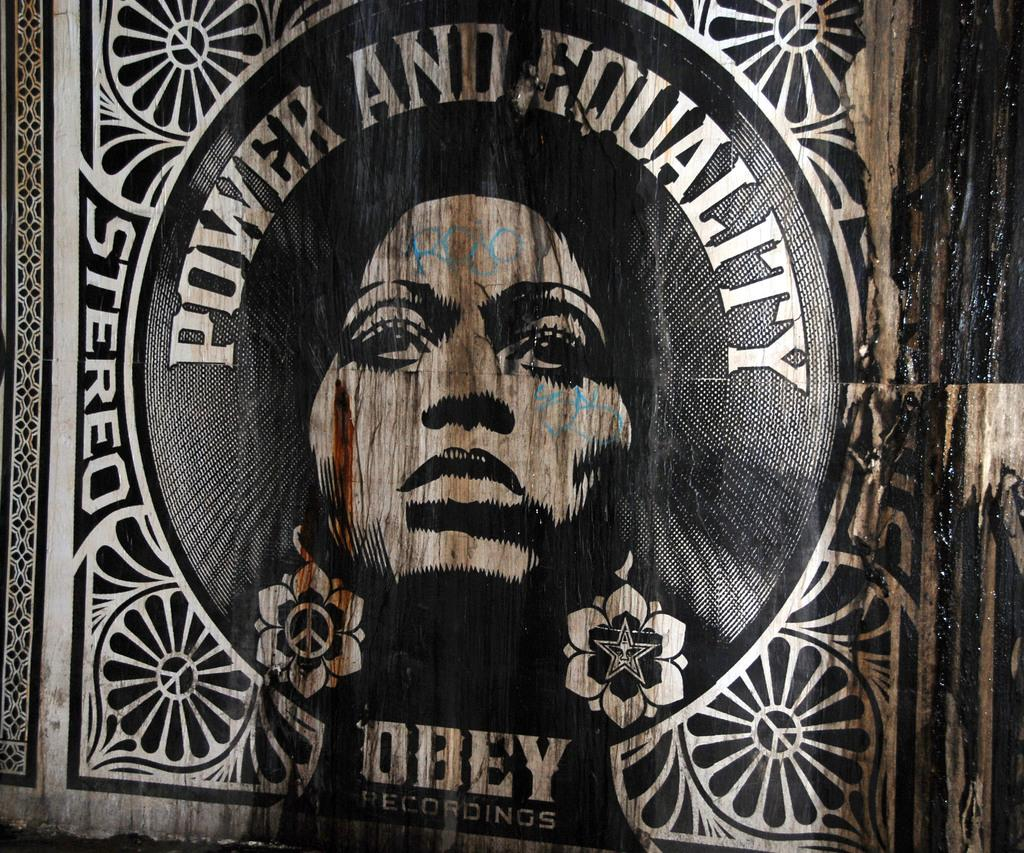What is the main object in the image? There is a poster in the image. Can you describe the position of the poster? The poster is in the front. What is depicted on the poster? The poster contains a person. Are there any other elements on the poster besides the person? Yes, the poster has some text and designs. Is there a cobweb visible on the poster in the image? No, there is no cobweb visible on the poster in the image. What type of harmony is being portrayed by the person on the poster? The image does not provide information about any harmony being portrayed by the person on the poster. 